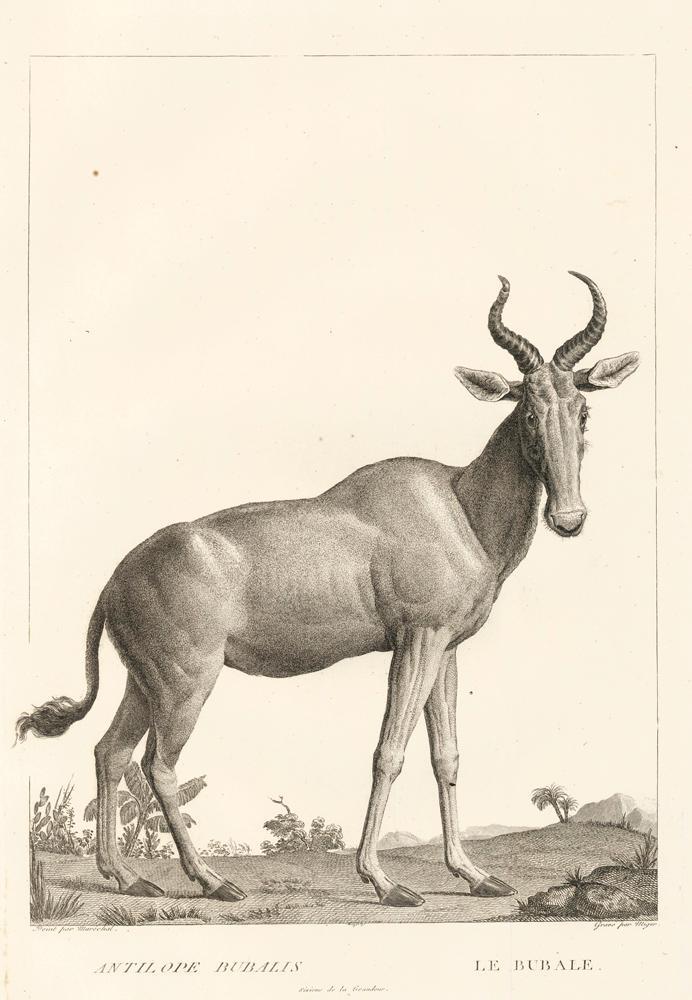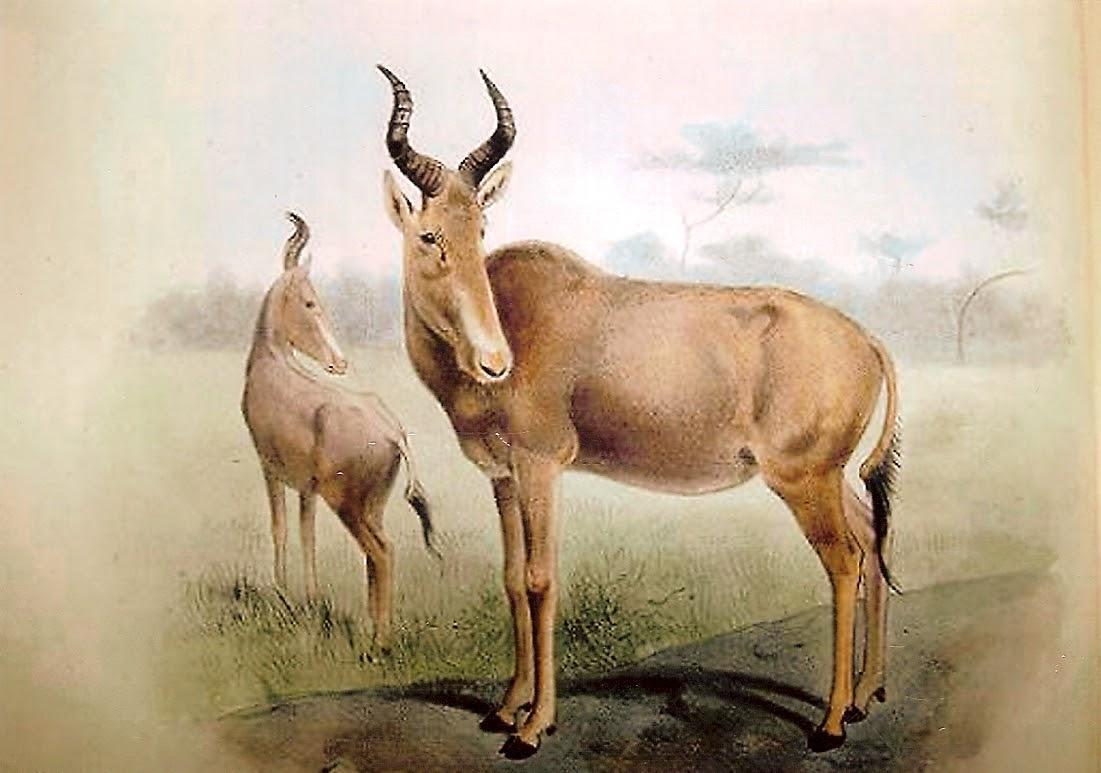The first image is the image on the left, the second image is the image on the right. Analyze the images presented: Is the assertion "Each image includes exactly one upright (standing) horned animal with its body in profile." valid? Answer yes or no. No. 